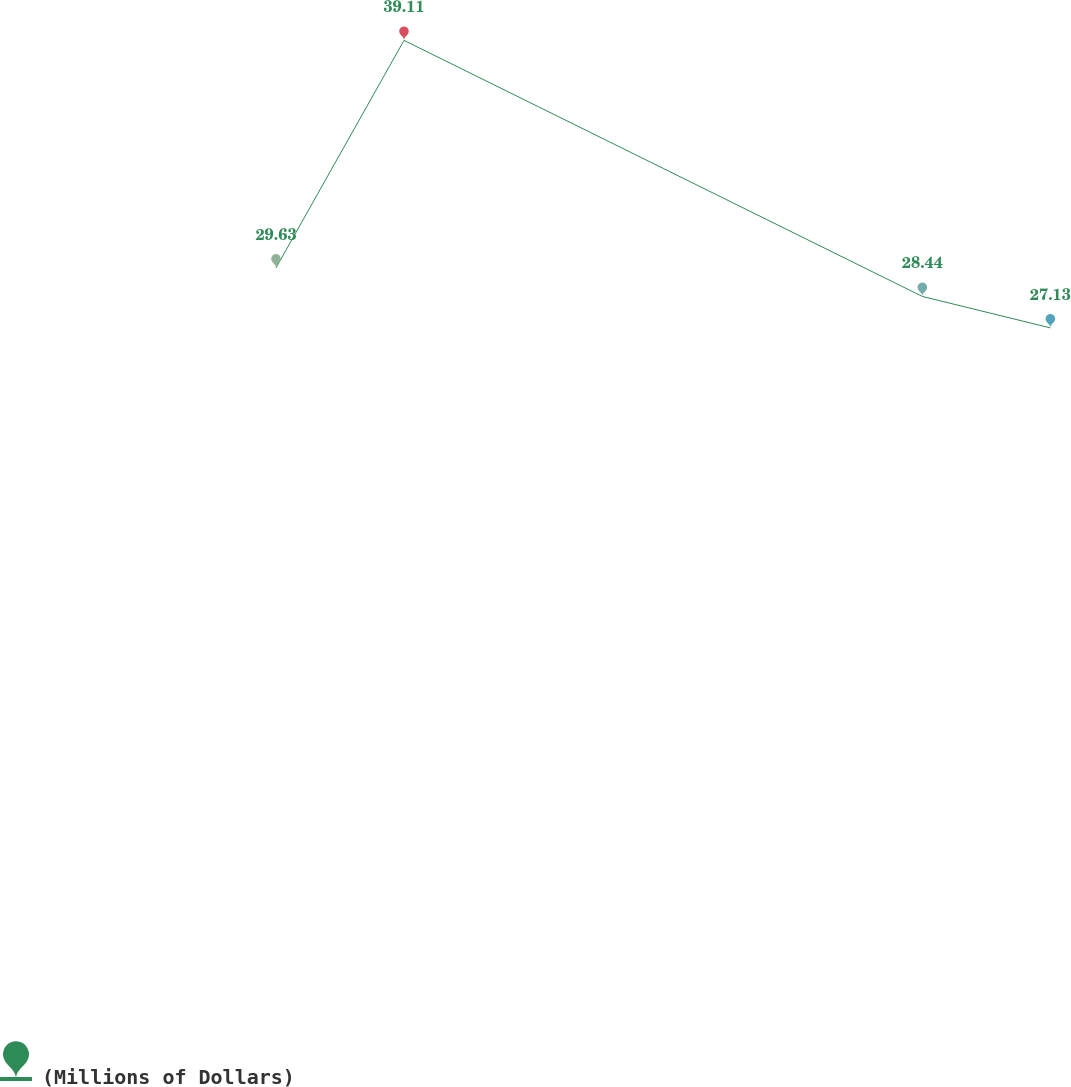<chart> <loc_0><loc_0><loc_500><loc_500><line_chart><ecel><fcel>(Millions of Dollars)<nl><fcel>1920.22<fcel>29.63<nl><fcel>1967.87<fcel>39.11<nl><fcel>2160.82<fcel>28.44<nl><fcel>2208.47<fcel>27.13<nl><fcel>2396.68<fcel>37.92<nl></chart> 